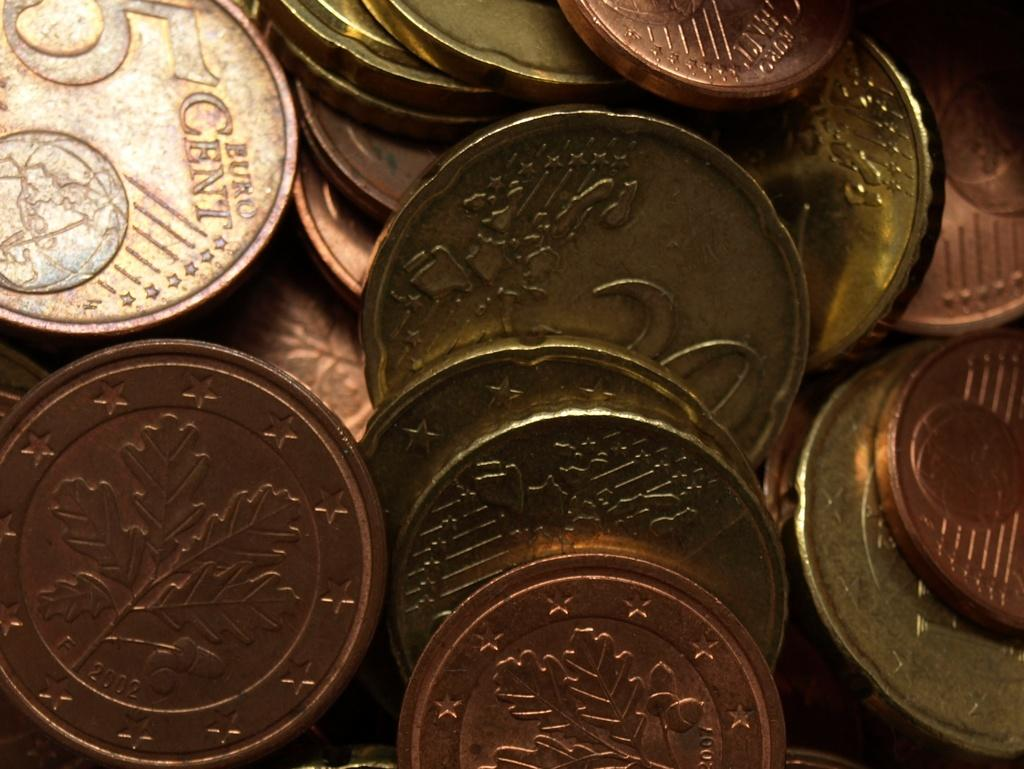Provide a one-sentence caption for the provided image. coins of various denominations including a 5 cent euro. 